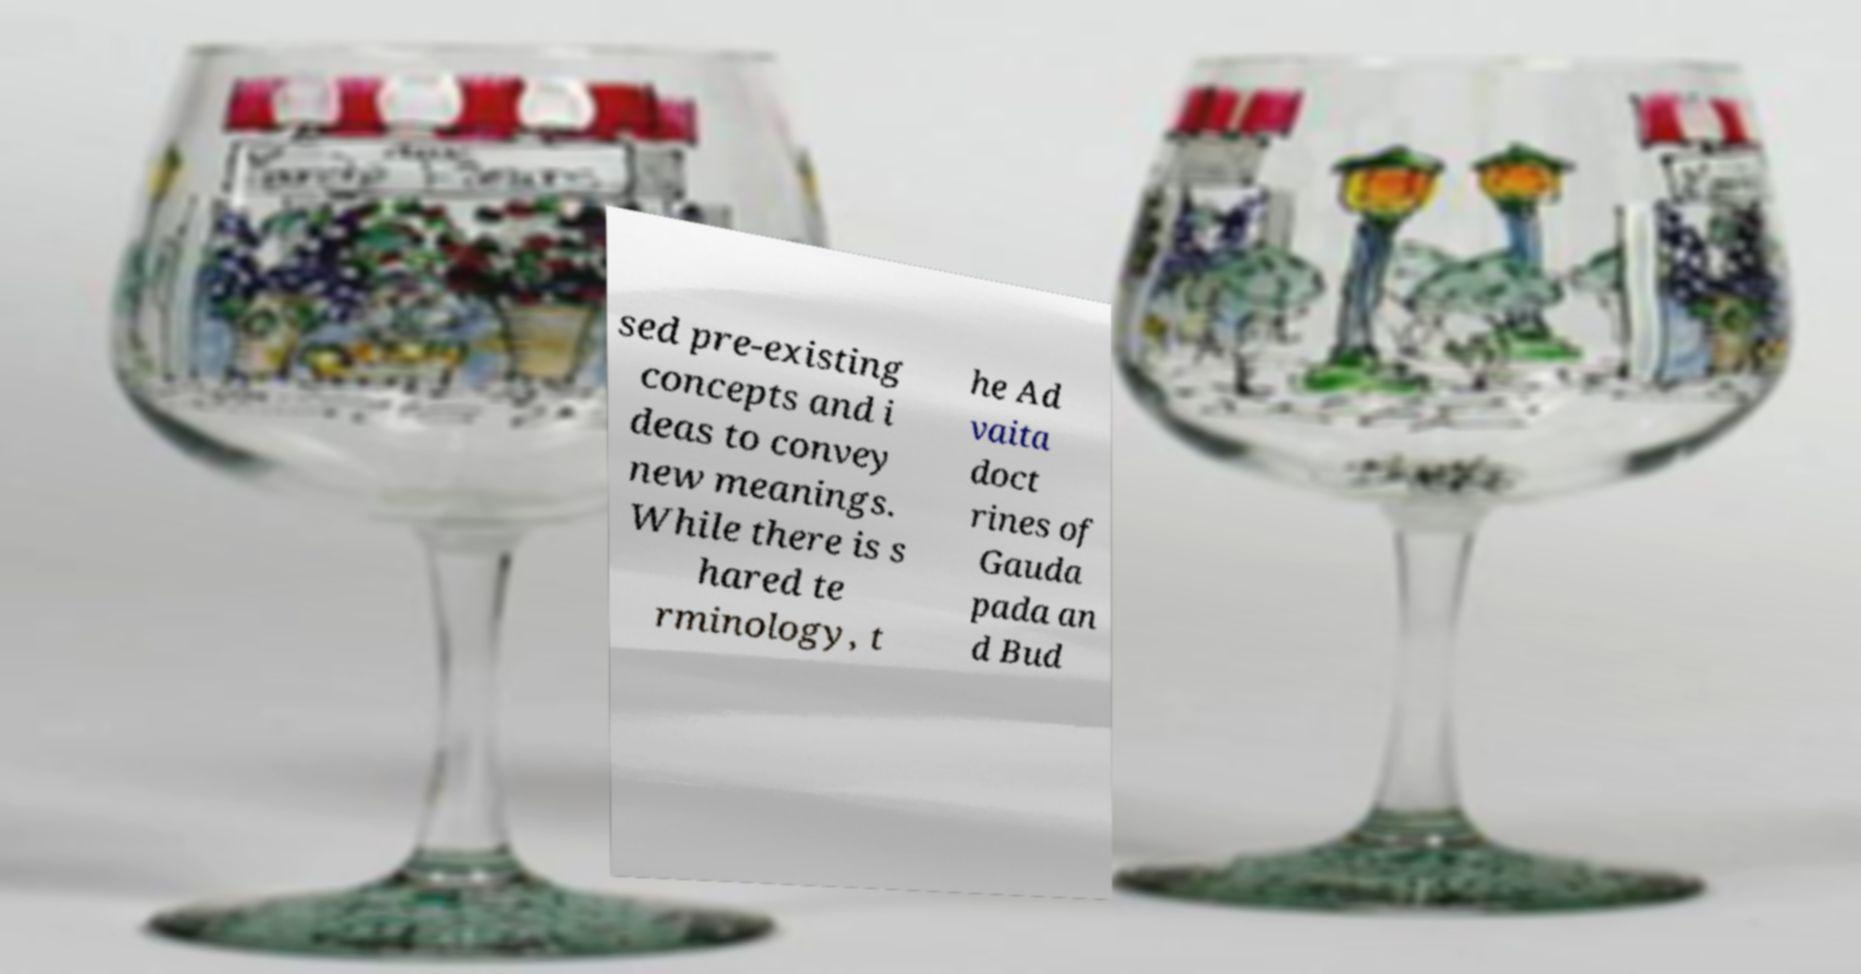What messages or text are displayed in this image? I need them in a readable, typed format. sed pre-existing concepts and i deas to convey new meanings. While there is s hared te rminology, t he Ad vaita doct rines of Gauda pada an d Bud 